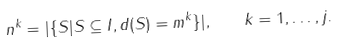Convert formula to latex. <formula><loc_0><loc_0><loc_500><loc_500>n ^ { k } = | \{ S | S \subseteq I , d ( S ) = m ^ { k } \} | , \quad k = 1 , \dots , j .</formula> 